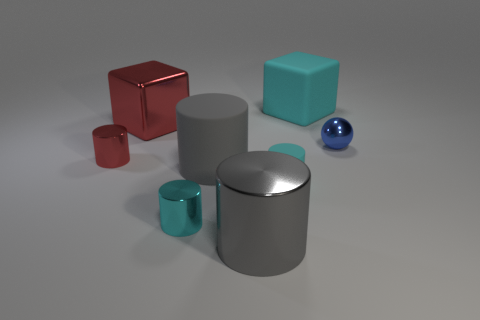Are there any big red metal objects of the same shape as the big gray rubber thing?
Provide a short and direct response. No. How many things are cyan cylinders to the left of the tiny matte cylinder or cyan matte things?
Offer a terse response. 3. Is the number of tiny cyan rubber cylinders greater than the number of shiny cylinders?
Make the answer very short. No. Are there any yellow shiny cylinders that have the same size as the rubber block?
Your response must be concise. No. How many things are either big matte things that are in front of the sphere or small matte cylinders to the right of the gray matte object?
Provide a succinct answer. 2. There is a large metallic object in front of the cyan cylinder that is left of the large gray rubber cylinder; what is its color?
Your answer should be compact. Gray. There is a cube that is the same material as the tiny blue ball; what is its color?
Provide a succinct answer. Red. What number of big things are the same color as the large matte cylinder?
Your answer should be very brief. 1. How many things are either small red objects or tiny cyan objects?
Your answer should be compact. 3. There is a cyan object that is the same size as the gray rubber object; what shape is it?
Provide a short and direct response. Cube. 